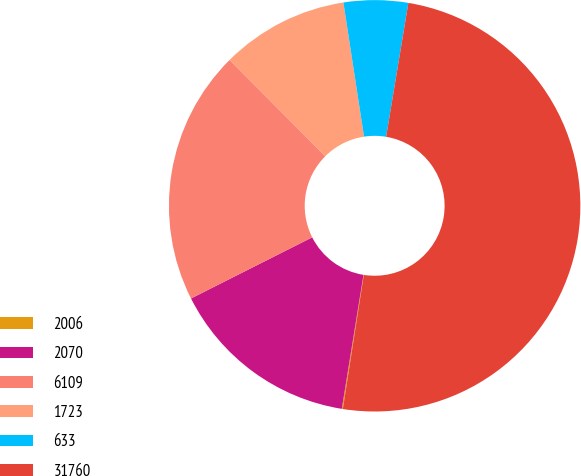Convert chart to OTSL. <chart><loc_0><loc_0><loc_500><loc_500><pie_chart><fcel>2006<fcel>2070<fcel>6109<fcel>1723<fcel>633<fcel>31760<nl><fcel>0.08%<fcel>15.01%<fcel>19.98%<fcel>10.03%<fcel>5.05%<fcel>49.85%<nl></chart> 